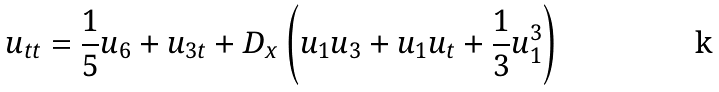<formula> <loc_0><loc_0><loc_500><loc_500>u _ { t t } = \frac { 1 } { 5 } u _ { 6 } + u _ { 3 t } + D _ { x } \left ( u _ { 1 } u _ { 3 } + u _ { 1 } u _ { t } + \frac { 1 } { 3 } u _ { 1 } ^ { 3 } \right )</formula> 